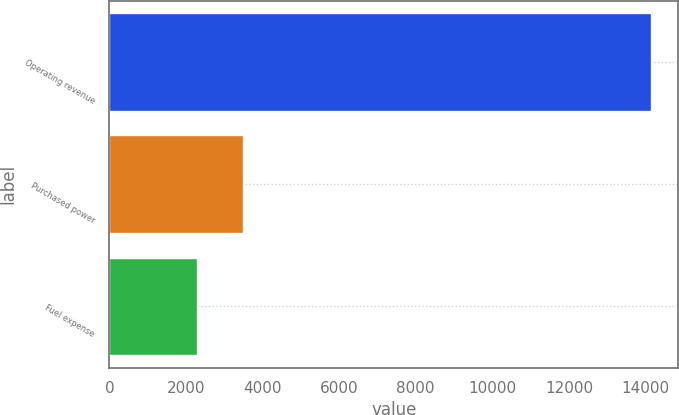Convert chart. <chart><loc_0><loc_0><loc_500><loc_500><bar_chart><fcel>Operating revenue<fcel>Purchased power<fcel>Fuel expense<nl><fcel>14152<fcel>3485.2<fcel>2300<nl></chart> 